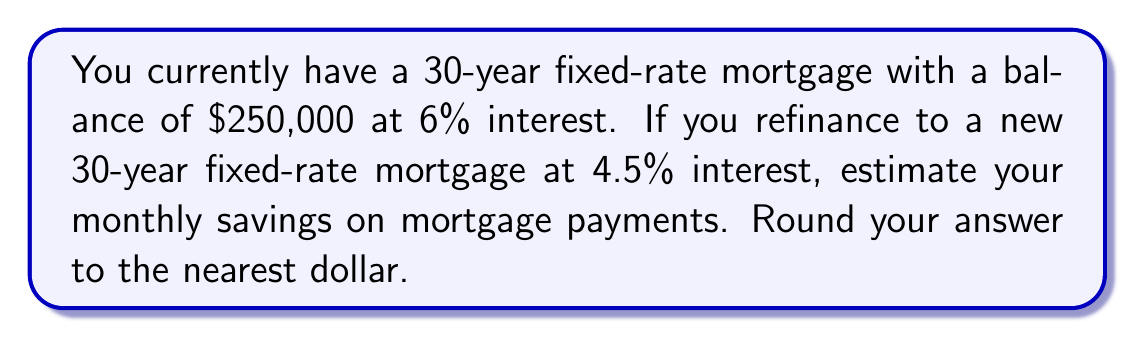Can you solve this math problem? Let's approach this step-by-step:

1. Calculate the monthly payment for the current mortgage:
   - Use the formula: $P = L\frac{r(1+r)^n}{(1+r)^n-1}$
   Where P = monthly payment, L = loan amount, r = monthly interest rate, n = total number of months
   
   $r = \frac{6\%}{12} = 0.005$ (monthly rate)
   $n = 30 \times 12 = 360$ (months)
   
   $$P_1 = 250000 \times \frac{0.005(1+0.005)^{360}}{(1+0.005)^{360}-1} \approx 1498.88$$

2. Calculate the monthly payment for the refinanced mortgage:
   $r = \frac{4.5\%}{12} = 0.00375$ (monthly rate)
   
   $$P_2 = 250000 \times \frac{0.00375(1+0.00375)^{360}}{(1+0.00375)^{360}-1} \approx 1266.71$$

3. Calculate the difference:
   $$\text{Monthly Savings} = P_1 - P_2 = 1498.88 - 1266.71 = 232.17$$

4. Round to the nearest dollar:
   $232.17 \approx 232$
Answer: $232 